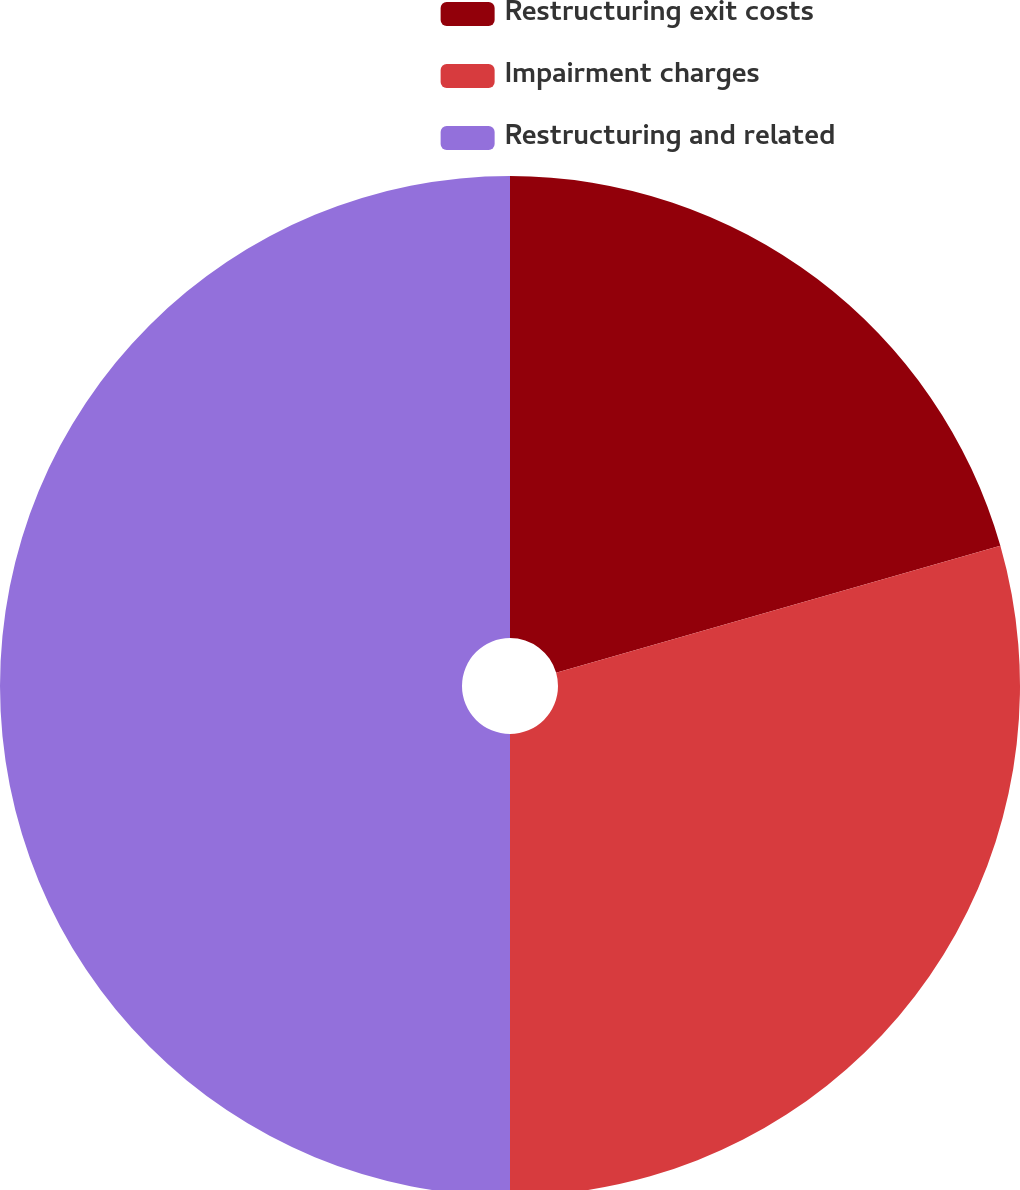<chart> <loc_0><loc_0><loc_500><loc_500><pie_chart><fcel>Restructuring exit costs<fcel>Impairment charges<fcel>Restructuring and related<nl><fcel>20.57%<fcel>29.43%<fcel>50.0%<nl></chart> 